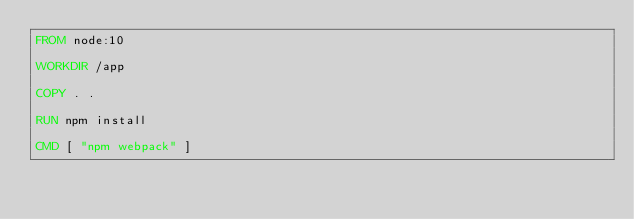Convert code to text. <code><loc_0><loc_0><loc_500><loc_500><_Dockerfile_>FROM node:10

WORKDIR /app

COPY . .

RUN npm install

CMD [ "npm webpack" ]</code> 